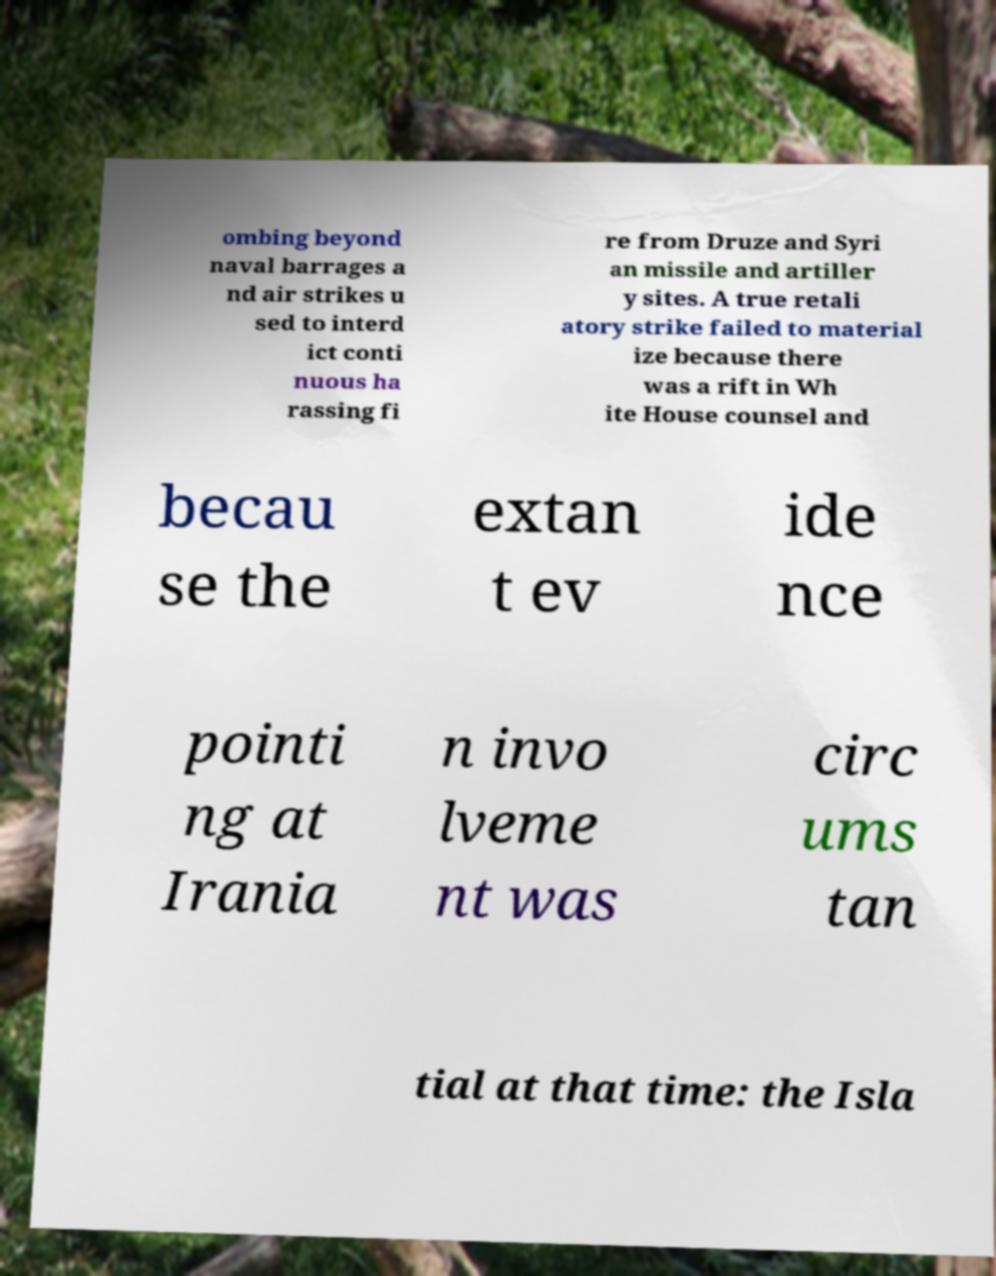Please identify and transcribe the text found in this image. ombing beyond naval barrages a nd air strikes u sed to interd ict conti nuous ha rassing fi re from Druze and Syri an missile and artiller y sites. A true retali atory strike failed to material ize because there was a rift in Wh ite House counsel and becau se the extan t ev ide nce pointi ng at Irania n invo lveme nt was circ ums tan tial at that time: the Isla 